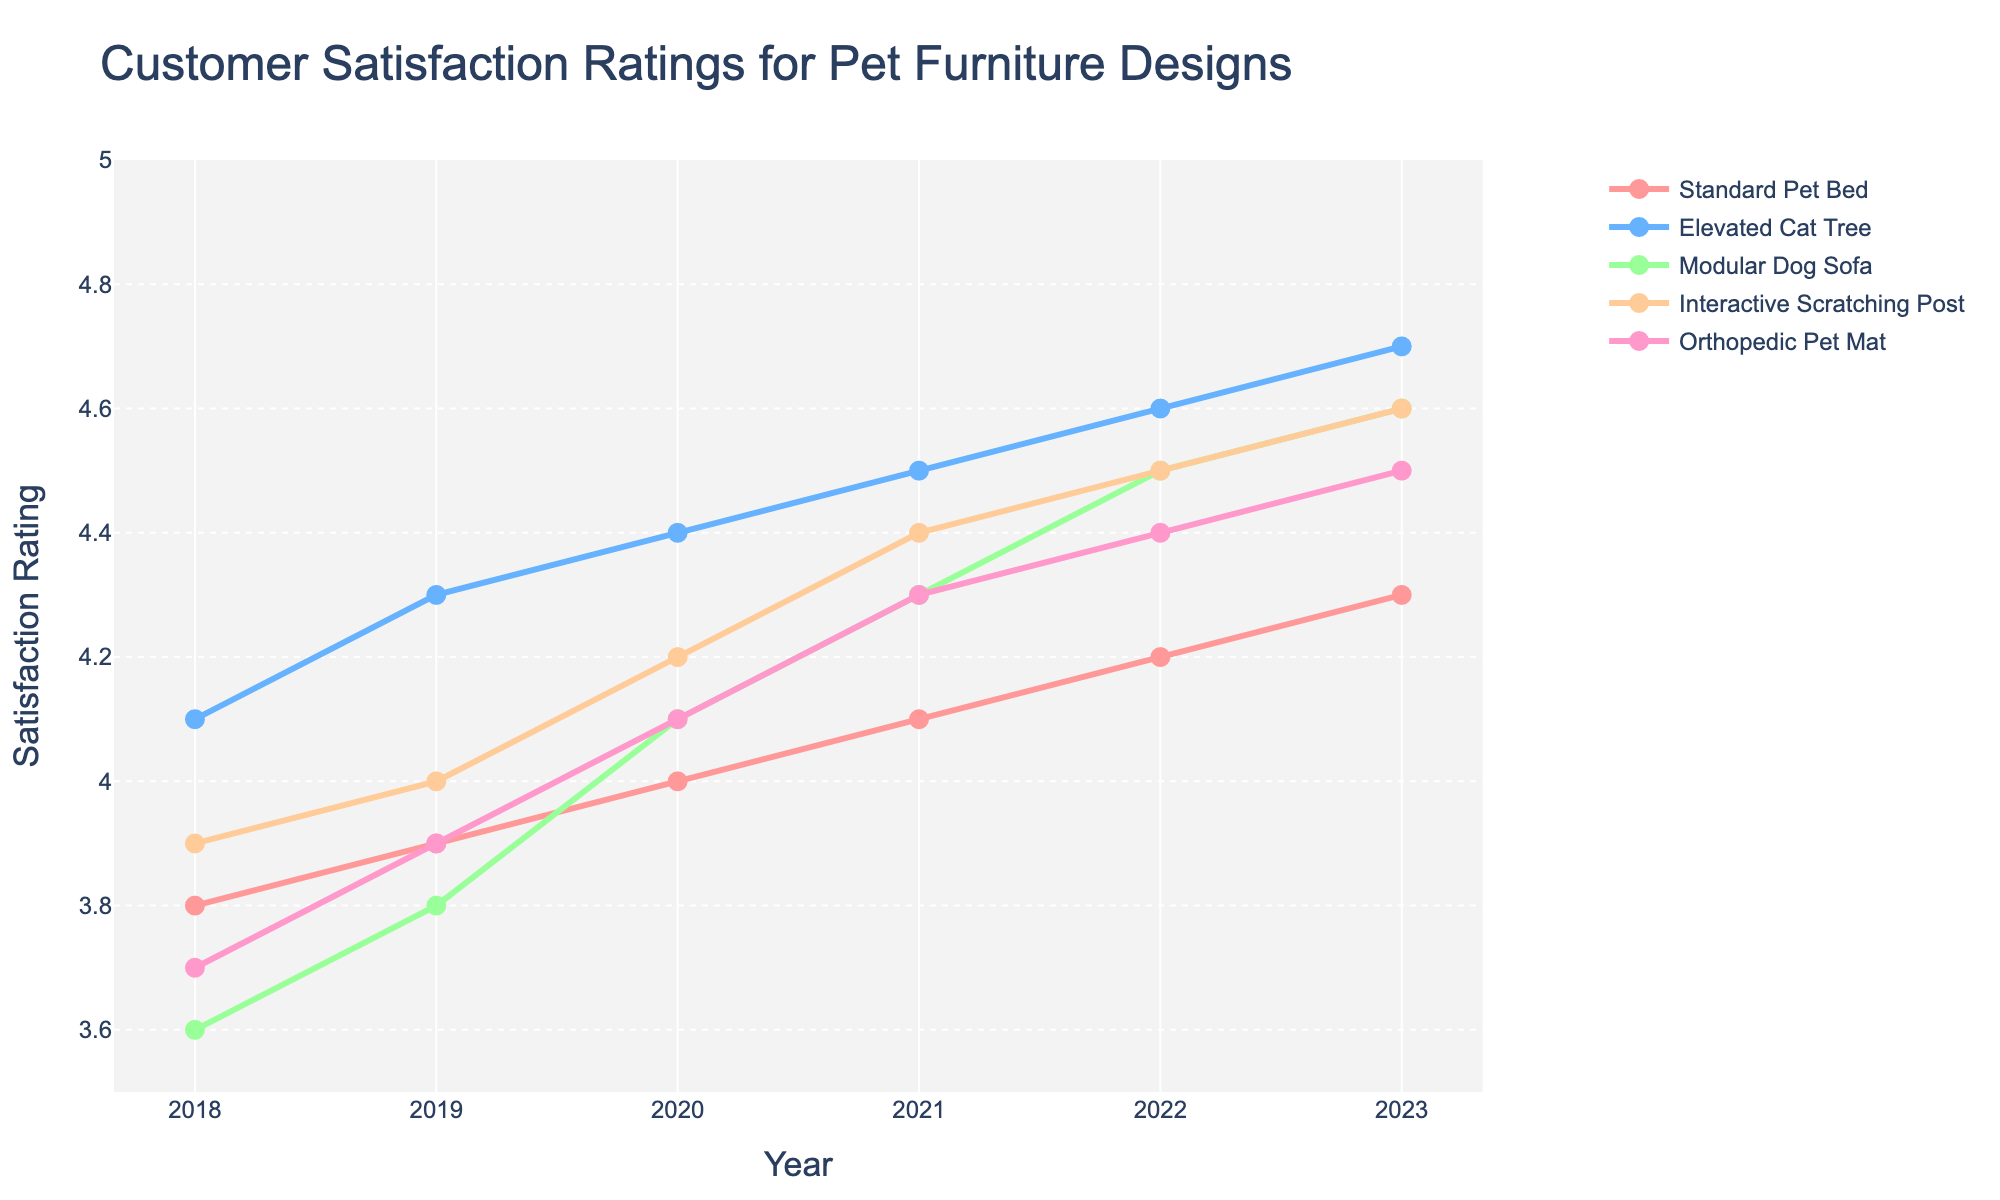How do the customer satisfaction ratings for the Standard Pet Bed change from 2018 to 2023? Look at the line representing the Standard Pet Bed. In 2018, the rating is 3.8, and it gradually increases each year, reaching 4.3 in 2023.
Answer: It increases from 3.8 to 4.3 Which pet furniture design had the highest customer satisfaction rating in 2023? Compare the points for all designs in 2023. The Elevated Cat Tree has the highest rating, which is 4.7.
Answer: Elevated Cat Tree What is the average customer satisfaction rating for the Orthopedic Pet Mat between 2018 and 2023? Add the ratings for 2018 to 2023 (3.7 + 3.9 + 4.1 + 4.3 + 4.4 + 4.5) and divide by the number of years (6). The total is 24.9, so the average is 24.9/6.
Answer: 4.15 Which year did the Modular Dog Sofa’s customer satisfaction rating surpass 4.0 for the first time? Observe the Modular Dog Sofa ratings over the years. The rating is below 4.0 until 2020 when it reaches 4.1 for the first time.
Answer: 2020 How many furniture designs had a customer satisfaction rating equal to or greater than 4.5 in 2022? Look at the ratings for all furniture designs in 2022. The Elevated Cat Tree, Modular Dog Sofa, Interactive Scratching Post each have ratings of 4.5 or higher. Count these occurrences.
Answer: Three Which pet furniture designs had a consistent increase in customer satisfaction every year from 2018 to 2023? Trace each design’s ratings across the years to see if they consistently rise without dips. The Elevated Cat Tree and Orthopedic Pet Mat show consistent increases.
Answer: Elevated Cat Tree and Orthopedic Pet Mat In which year did the Standard Pet Bed and Interactive Scratching Post have the smallest difference in their customer satisfaction ratings? Subtract the ratings of the two designs for each year and find the year with the smallest absolute difference. In 2018, the difference is 0.1 (3.9 - 3.8), which is the smallest difference among all years.
Answer: 2018 